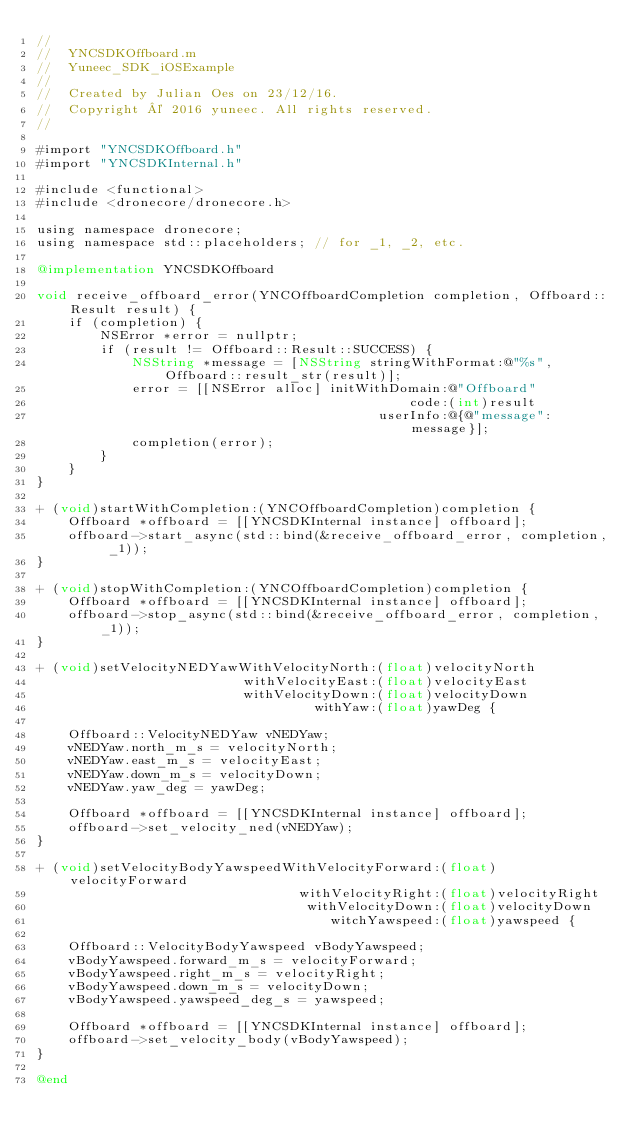<code> <loc_0><loc_0><loc_500><loc_500><_ObjectiveC_>//
//  YNCSDKOffboard.m
//  Yuneec_SDK_iOSExample
//
//  Created by Julian Oes on 23/12/16.
//  Copyright © 2016 yuneec. All rights reserved.
//

#import "YNCSDKOffboard.h"
#import "YNCSDKInternal.h"

#include <functional>
#include <dronecore/dronecore.h>

using namespace dronecore;
using namespace std::placeholders; // for _1, _2, etc.

@implementation YNCSDKOffboard

void receive_offboard_error(YNCOffboardCompletion completion, Offboard::Result result) {
    if (completion) {
        NSError *error = nullptr;
        if (result != Offboard::Result::SUCCESS) {
            NSString *message = [NSString stringWithFormat:@"%s", Offboard::result_str(result)];
            error = [[NSError alloc] initWithDomain:@"Offboard"
                                               code:(int)result
                                           userInfo:@{@"message": message}];
            completion(error);
        }
    }
}

+ (void)startWithCompletion:(YNCOffboardCompletion)completion {
    Offboard *offboard = [[YNCSDKInternal instance] offboard];
    offboard->start_async(std::bind(&receive_offboard_error, completion, _1));
}

+ (void)stopWithCompletion:(YNCOffboardCompletion)completion {
    Offboard *offboard = [[YNCSDKInternal instance] offboard];
    offboard->stop_async(std::bind(&receive_offboard_error, completion, _1));
}

+ (void)setVelocityNEDYawWithVelocityNorth:(float)velocityNorth
                          withVelocityEast:(float)velocityEast
                          withVelocityDown:(float)velocityDown
                                   withYaw:(float)yawDeg {

    Offboard::VelocityNEDYaw vNEDYaw;
    vNEDYaw.north_m_s = velocityNorth;
    vNEDYaw.east_m_s = velocityEast;
    vNEDYaw.down_m_s = velocityDown;
    vNEDYaw.yaw_deg = yawDeg;

    Offboard *offboard = [[YNCSDKInternal instance] offboard];
    offboard->set_velocity_ned(vNEDYaw);
}

+ (void)setVelocityBodyYawspeedWithVelocityForward:(float)velocityForward
                                 withVelocityRight:(float)velocityRight
                                  withVelocityDown:(float)velocityDown
                                     witchYawspeed:(float)yawspeed {

    Offboard::VelocityBodyYawspeed vBodyYawspeed;
    vBodyYawspeed.forward_m_s = velocityForward;
    vBodyYawspeed.right_m_s = velocityRight;
    vBodyYawspeed.down_m_s = velocityDown;
    vBodyYawspeed.yawspeed_deg_s = yawspeed;

    Offboard *offboard = [[YNCSDKInternal instance] offboard];
    offboard->set_velocity_body(vBodyYawspeed);
}

@end
</code> 